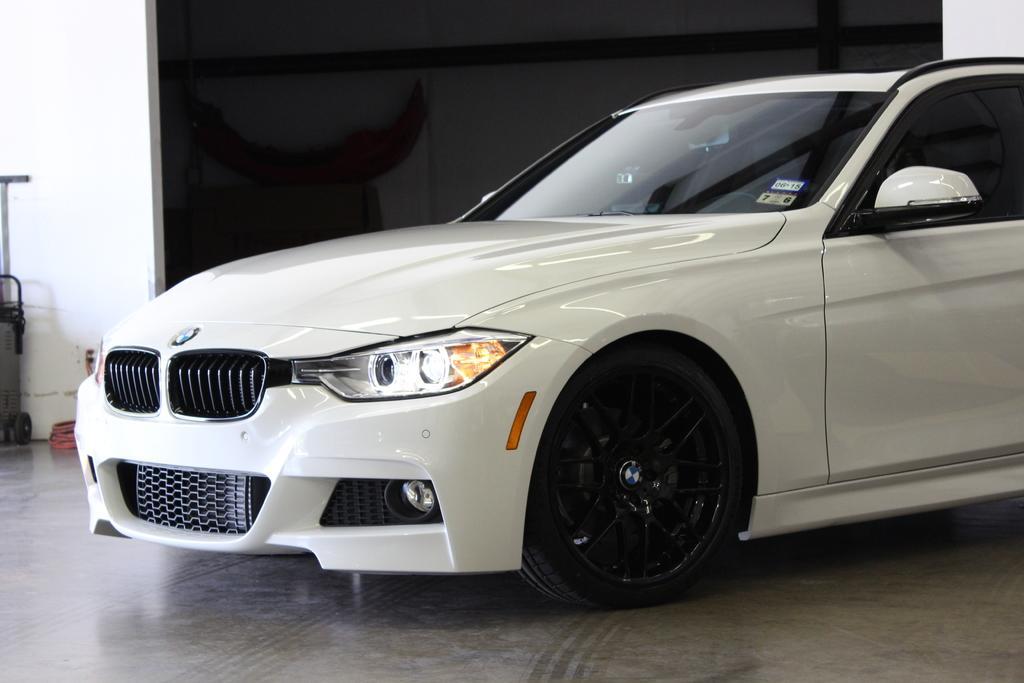Could you give a brief overview of what you see in this image? In this picture there is a white car. At the back it looks like a mirror and there is a wall. On the left side of the image there is an object and there it looks like a pipe. At the bottom there is a floor. 